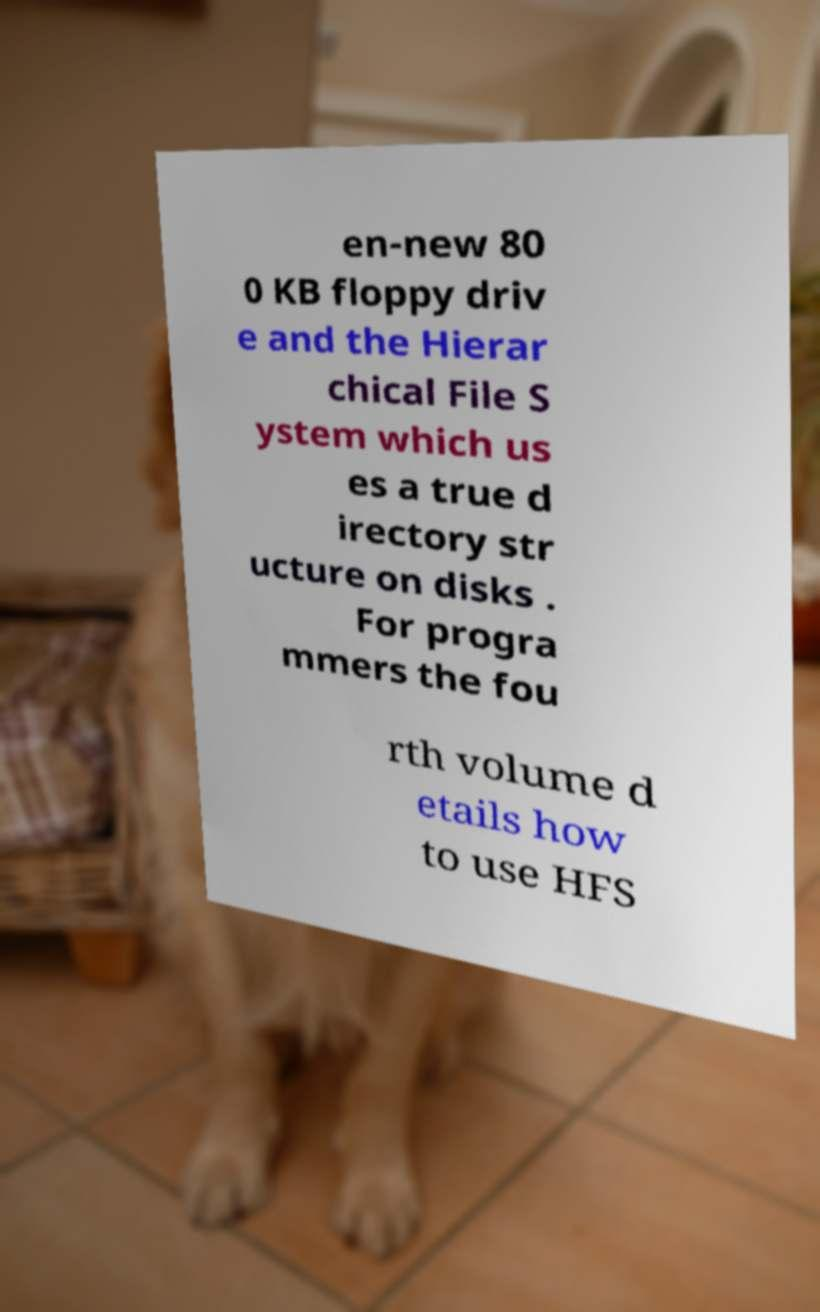There's text embedded in this image that I need extracted. Can you transcribe it verbatim? en-new 80 0 KB floppy driv e and the Hierar chical File S ystem which us es a true d irectory str ucture on disks . For progra mmers the fou rth volume d etails how to use HFS 